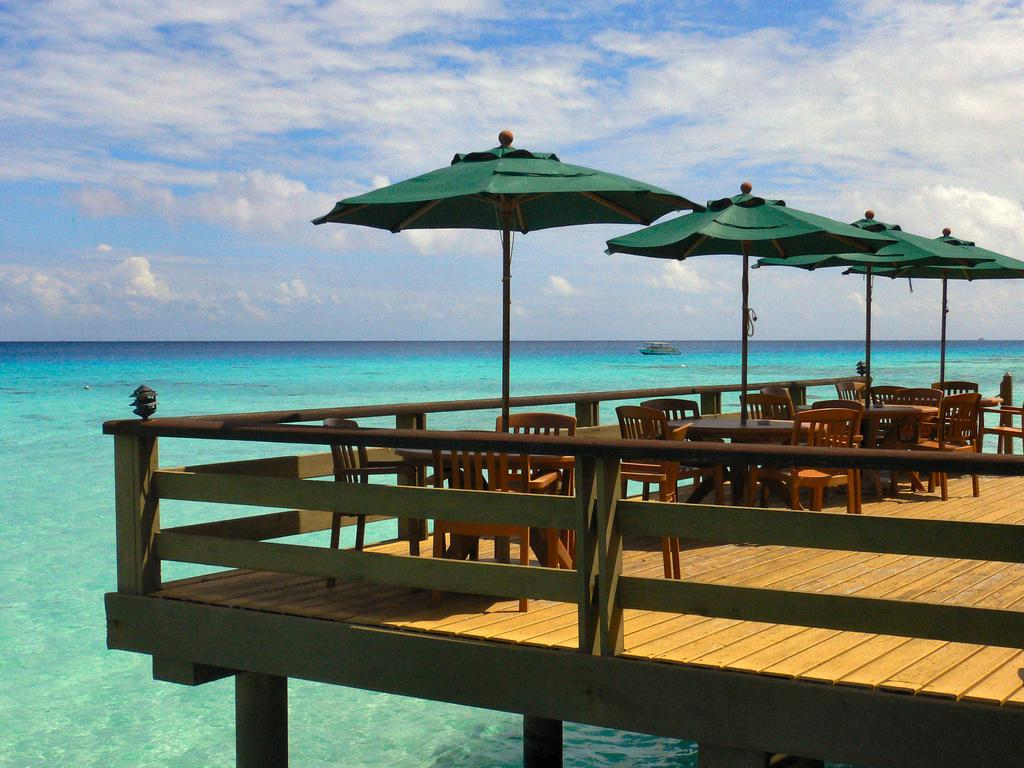What type of furniture is present in the image? There are chairs and tables in the image. What objects provide shade in the image? There are umbrellas in the image. What type of barrier is visible in the image? There is a fence in the image. What is on the water in the image? There is a ship on the water in the image. What part of the natural environment is visible in the background of the image? There is sky visible in the background of the image. What can be seen in the sky? There are clouds in the sky. What type of iron is being used by the people in the image? There is no iron present in the image; it features chairs, tables, umbrellas, a fence, a ship on the water, and clouds in the sky. How many people are coughing in the image? There is no indication of anyone coughing in the image. 